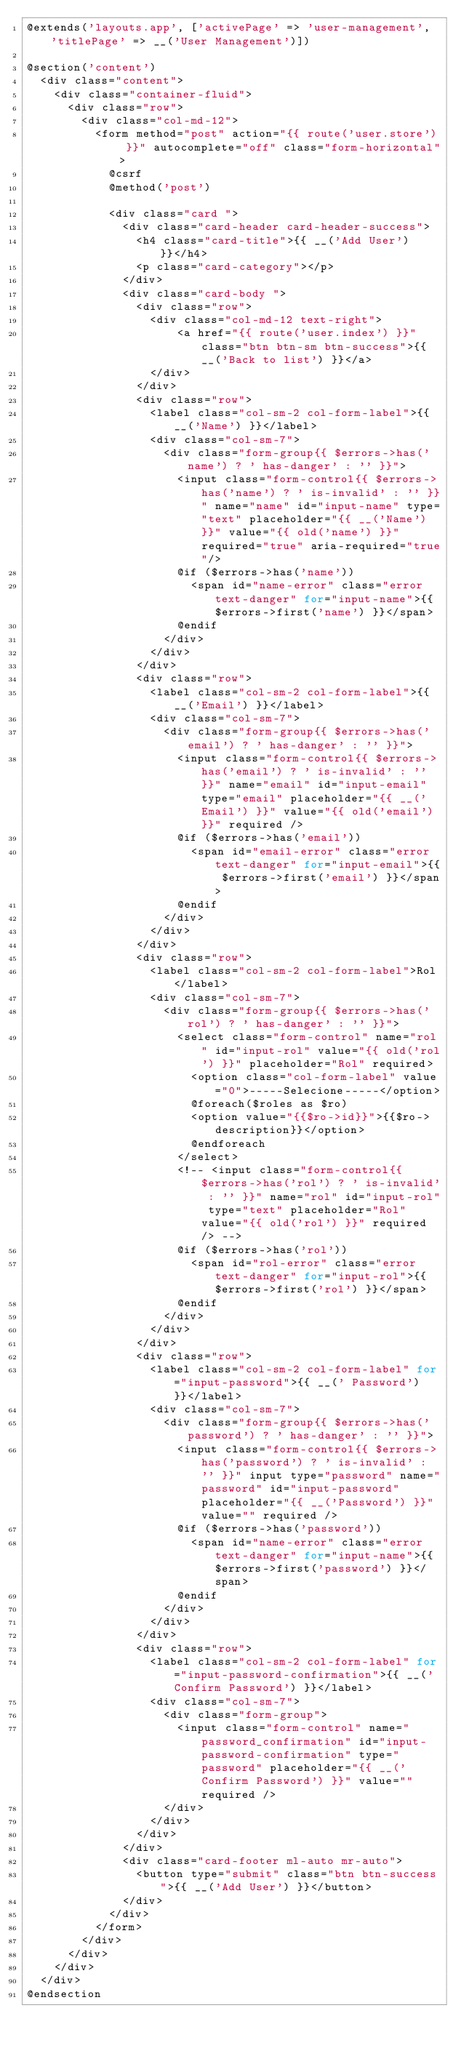<code> <loc_0><loc_0><loc_500><loc_500><_PHP_>@extends('layouts.app', ['activePage' => 'user-management', 'titlePage' => __('User Management')])

@section('content')
  <div class="content">
    <div class="container-fluid">
      <div class="row">
        <div class="col-md-12">
          <form method="post" action="{{ route('user.store') }}" autocomplete="off" class="form-horizontal">
            @csrf
            @method('post')

            <div class="card ">
              <div class="card-header card-header-success">
                <h4 class="card-title">{{ __('Add User') }}</h4>
                <p class="card-category"></p>
              </div>
              <div class="card-body ">
                <div class="row">
                  <div class="col-md-12 text-right">
                      <a href="{{ route('user.index') }}" class="btn btn-sm btn-success">{{ __('Back to list') }}</a>
                  </div>
                </div>
                <div class="row">
                  <label class="col-sm-2 col-form-label">{{ __('Name') }}</label>
                  <div class="col-sm-7">
                    <div class="form-group{{ $errors->has('name') ? ' has-danger' : '' }}">
                      <input class="form-control{{ $errors->has('name') ? ' is-invalid' : '' }}" name="name" id="input-name" type="text" placeholder="{{ __('Name') }}" value="{{ old('name') }}" required="true" aria-required="true"/>
                      @if ($errors->has('name'))
                        <span id="name-error" class="error text-danger" for="input-name">{{ $errors->first('name') }}</span>
                      @endif
                    </div>
                  </div>
                </div>
                <div class="row">
                  <label class="col-sm-2 col-form-label">{{ __('Email') }}</label>
                  <div class="col-sm-7">
                    <div class="form-group{{ $errors->has('email') ? ' has-danger' : '' }}">
                      <input class="form-control{{ $errors->has('email') ? ' is-invalid' : '' }}" name="email" id="input-email" type="email" placeholder="{{ __('Email') }}" value="{{ old('email') }}" required />
                      @if ($errors->has('email'))
                        <span id="email-error" class="error text-danger" for="input-email">{{ $errors->first('email') }}</span>
                      @endif
                    </div>
                  </div>
                </div>
                <div class="row">
                  <label class="col-sm-2 col-form-label">Rol</label>
                  <div class="col-sm-7">
                    <div class="form-group{{ $errors->has('rol') ? ' has-danger' : '' }}">
                      <select class="form-control" name="rol" id="input-rol" value="{{ old('rol') }}" placeholder="Rol" required>
                        <option class="col-form-label" value="0">-----Selecione-----</option>
                        @foreach($roles as $ro)
                        <option value="{{$ro->id}}">{{$ro->description}}</option>
                        @endforeach
                      </select>
                      <!-- <input class="form-control{{ $errors->has('rol') ? ' is-invalid' : '' }}" name="rol" id="input-rol" type="text" placeholder="Rol" value="{{ old('rol') }}" required /> -->
                      @if ($errors->has('rol'))
                        <span id="rol-error" class="error text-danger" for="input-rol">{{ $errors->first('rol') }}</span>
                      @endif
                    </div>
                  </div>
                </div>
                <div class="row">
                  <label class="col-sm-2 col-form-label" for="input-password">{{ __(' Password') }}</label>
                  <div class="col-sm-7">
                    <div class="form-group{{ $errors->has('password') ? ' has-danger' : '' }}">
                      <input class="form-control{{ $errors->has('password') ? ' is-invalid' : '' }}" input type="password" name="password" id="input-password" placeholder="{{ __('Password') }}" value="" required />
                      @if ($errors->has('password'))
                        <span id="name-error" class="error text-danger" for="input-name">{{ $errors->first('password') }}</span>
                      @endif
                    </div>
                  </div>
                </div>
                <div class="row">
                  <label class="col-sm-2 col-form-label" for="input-password-confirmation">{{ __('Confirm Password') }}</label>
                  <div class="col-sm-7">
                    <div class="form-group">
                      <input class="form-control" name="password_confirmation" id="input-password-confirmation" type="password" placeholder="{{ __('Confirm Password') }}" value="" required />
                    </div>
                  </div>
                </div>
              </div>
              <div class="card-footer ml-auto mr-auto">
                <button type="submit" class="btn btn-success">{{ __('Add User') }}</button>
              </div>
            </div>
          </form>
        </div>
      </div>
    </div>
  </div>
@endsection</code> 